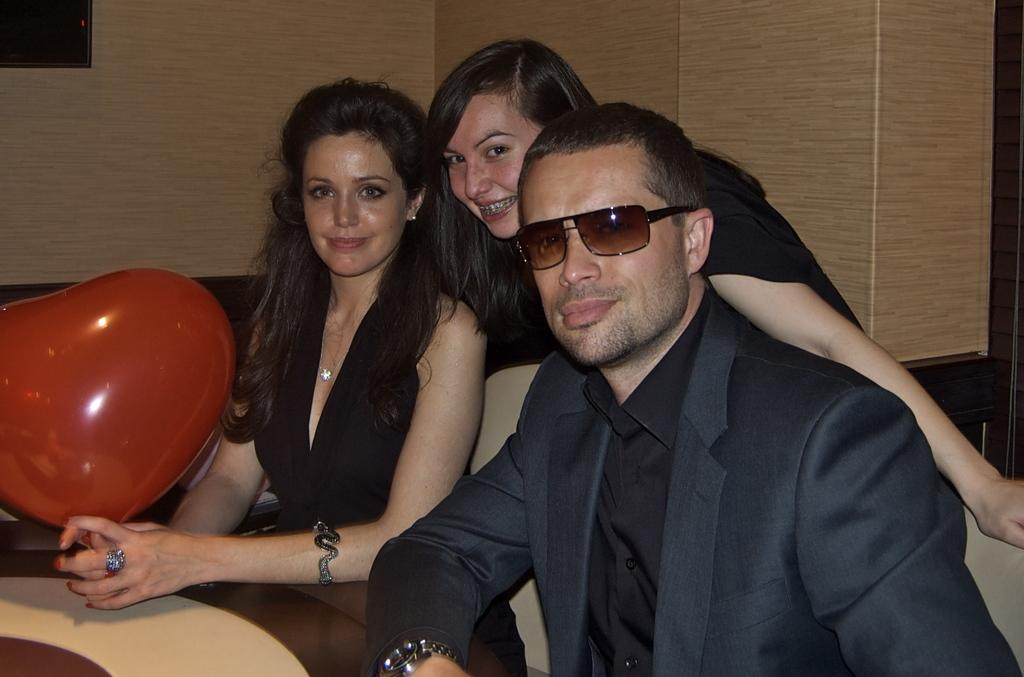How many people are in the room? There are 3 people in the room. What are the people wearing? All 3 people are wearing black dresses. What are the positions of the people in the room? Two people are sitting, and one person is standing. Can you describe the person who is wearing goggles? One person is wearing goggles, but we cannot determine any other details about them from the provided facts. What is the person holding a red balloon doing? We cannot determine what the person holding the red balloon is doing from the provided facts. How many dogs are in the room? There is no mention of dogs in the provided facts, so we cannot determine the number of dogs in the room. 